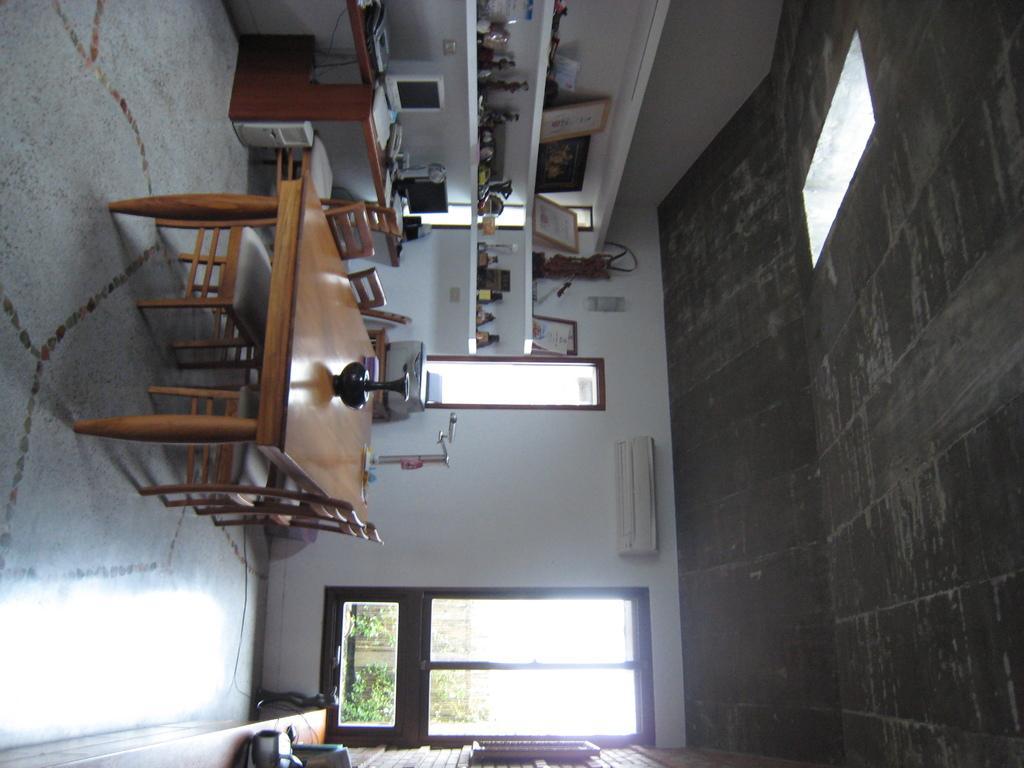Describe this image in one or two sentences. In this picture there is a table which has a flower vase placed on it and there are few chairs on either sides of it and there is a table which has few desktops and some other objects placed on it and there is an air conditioner attached to the wall in the background and there is a window beside it. 